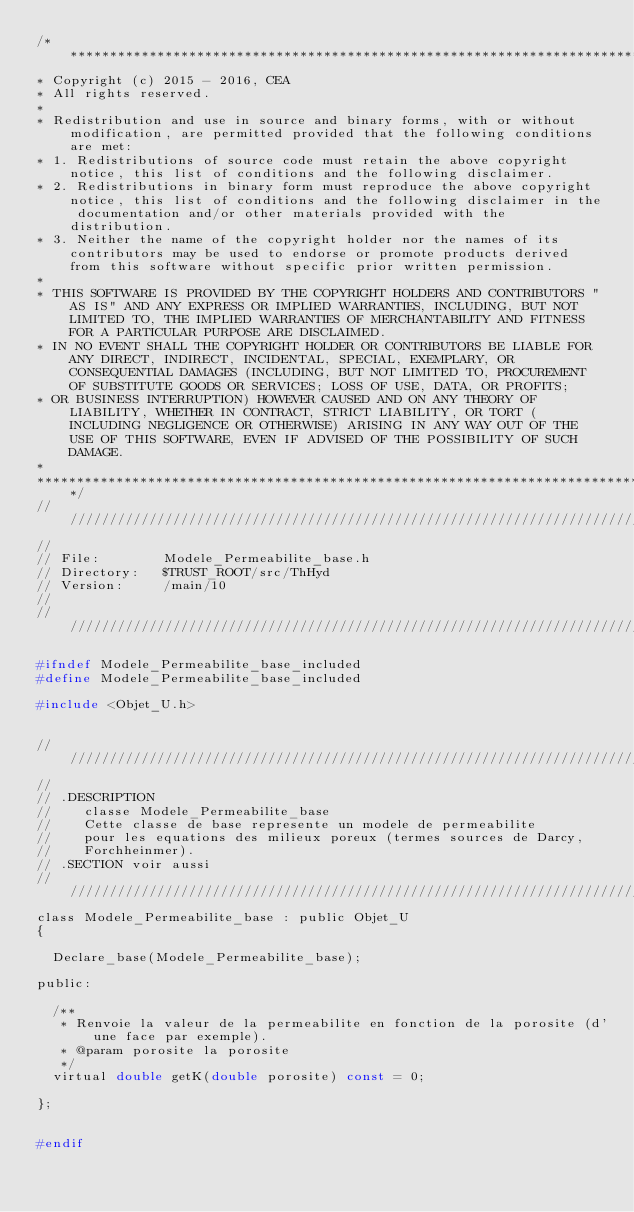Convert code to text. <code><loc_0><loc_0><loc_500><loc_500><_C_>/****************************************************************************
* Copyright (c) 2015 - 2016, CEA
* All rights reserved.
*
* Redistribution and use in source and binary forms, with or without modification, are permitted provided that the following conditions are met:
* 1. Redistributions of source code must retain the above copyright notice, this list of conditions and the following disclaimer.
* 2. Redistributions in binary form must reproduce the above copyright notice, this list of conditions and the following disclaimer in the documentation and/or other materials provided with the distribution.
* 3. Neither the name of the copyright holder nor the names of its contributors may be used to endorse or promote products derived from this software without specific prior written permission.
*
* THIS SOFTWARE IS PROVIDED BY THE COPYRIGHT HOLDERS AND CONTRIBUTORS "AS IS" AND ANY EXPRESS OR IMPLIED WARRANTIES, INCLUDING, BUT NOT LIMITED TO, THE IMPLIED WARRANTIES OF MERCHANTABILITY AND FITNESS FOR A PARTICULAR PURPOSE ARE DISCLAIMED.
* IN NO EVENT SHALL THE COPYRIGHT HOLDER OR CONTRIBUTORS BE LIABLE FOR ANY DIRECT, INDIRECT, INCIDENTAL, SPECIAL, EXEMPLARY, OR CONSEQUENTIAL DAMAGES (INCLUDING, BUT NOT LIMITED TO, PROCUREMENT OF SUBSTITUTE GOODS OR SERVICES; LOSS OF USE, DATA, OR PROFITS;
* OR BUSINESS INTERRUPTION) HOWEVER CAUSED AND ON ANY THEORY OF LIABILITY, WHETHER IN CONTRACT, STRICT LIABILITY, OR TORT (INCLUDING NEGLIGENCE OR OTHERWISE) ARISING IN ANY WAY OUT OF THE USE OF THIS SOFTWARE, EVEN IF ADVISED OF THE POSSIBILITY OF SUCH DAMAGE.
*
*****************************************************************************/
//////////////////////////////////////////////////////////////////////////////
//
// File:        Modele_Permeabilite_base.h
// Directory:   $TRUST_ROOT/src/ThHyd
// Version:     /main/10
//
//////////////////////////////////////////////////////////////////////////////

#ifndef Modele_Permeabilite_base_included
#define Modele_Permeabilite_base_included

#include <Objet_U.h>


//////////////////////////////////////////////////////////////////////////////
//
// .DESCRIPTION
//    classe Modele_Permeabilite_base
//    Cette classe de base represente un modele de permeabilite
//    pour les equations des milieux poreux (termes sources de Darcy,
//    Forchheinmer).
// .SECTION voir aussi
//////////////////////////////////////////////////////////////////////////////
class Modele_Permeabilite_base : public Objet_U
{

  Declare_base(Modele_Permeabilite_base);

public:

  /**
   * Renvoie la valeur de la permeabilite en fonction de la porosite (d'une face par exemple).
   * @param porosite la porosite
   */
  virtual double getK(double porosite) const = 0;

};


#endif


</code> 